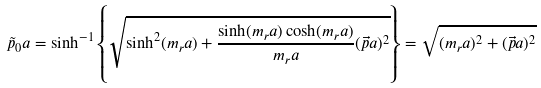<formula> <loc_0><loc_0><loc_500><loc_500>\tilde { p } _ { 0 } a = \sinh ^ { - 1 } \left \{ \sqrt { \sinh ^ { 2 } ( m _ { r } a ) + \frac { \sinh ( m _ { r } a ) \cosh ( m _ { r } a ) } { m _ { r } a } ( \vec { p } a ) ^ { 2 } } \right \} = \sqrt { ( m _ { r } a ) ^ { 2 } + ( \vec { p } a ) ^ { 2 } }</formula> 